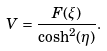Convert formula to latex. <formula><loc_0><loc_0><loc_500><loc_500>V = \frac { F ( \xi ) } { \cosh ^ { 2 } ( \eta ) } .</formula> 